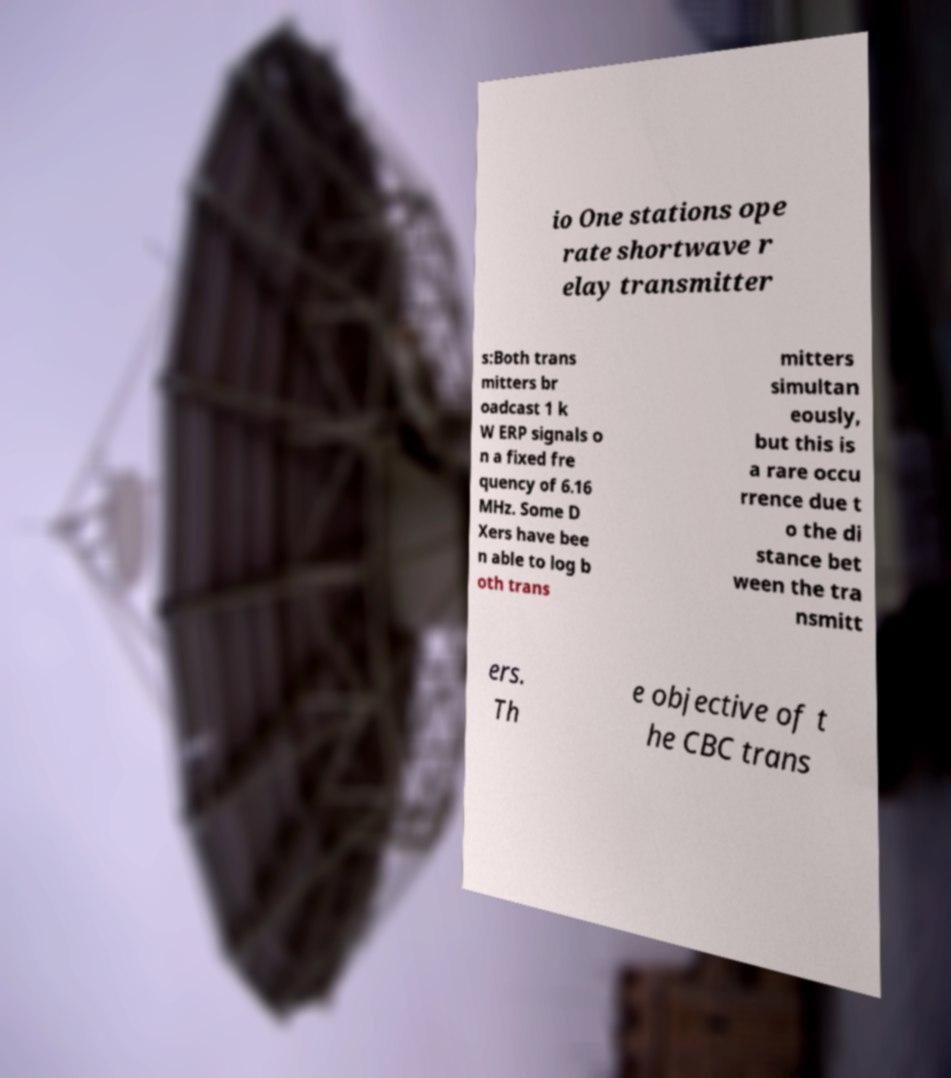Could you extract and type out the text from this image? io One stations ope rate shortwave r elay transmitter s:Both trans mitters br oadcast 1 k W ERP signals o n a fixed fre quency of 6.16 MHz. Some D Xers have bee n able to log b oth trans mitters simultan eously, but this is a rare occu rrence due t o the di stance bet ween the tra nsmitt ers. Th e objective of t he CBC trans 